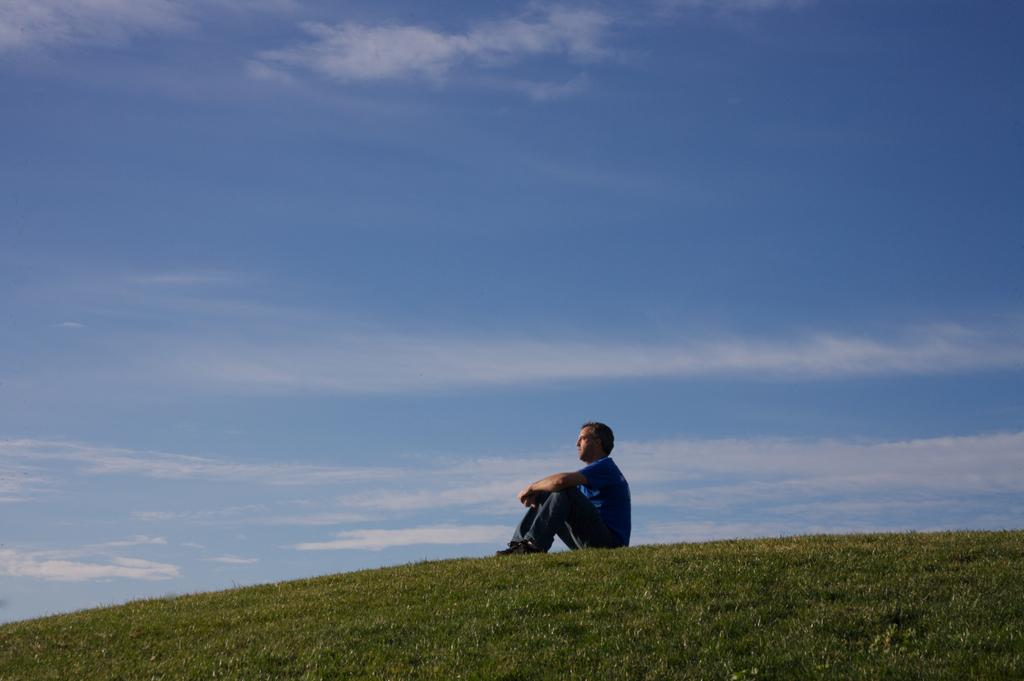What is the man in the image doing? The man is sitting in the image. What type of vegetation can be seen in the image? There is green grass visible in the image. What is the condition of the sky in the background of the image? The sky is clear in the background of the image. What type of bead is being used to decorate the border in the image? There is no bead or border present in the image. What holiday is being celebrated in the image? There is no indication of a holiday being celebrated in the image. 